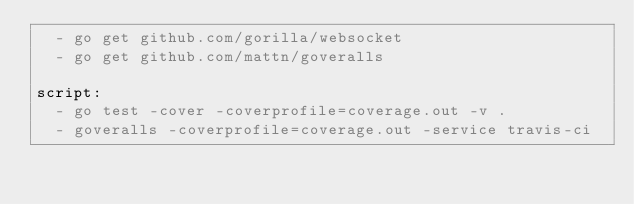Convert code to text. <code><loc_0><loc_0><loc_500><loc_500><_YAML_>  - go get github.com/gorilla/websocket
  - go get github.com/mattn/goveralls

script:
  - go test -cover -coverprofile=coverage.out -v .
  - goveralls -coverprofile=coverage.out -service travis-ci
</code> 